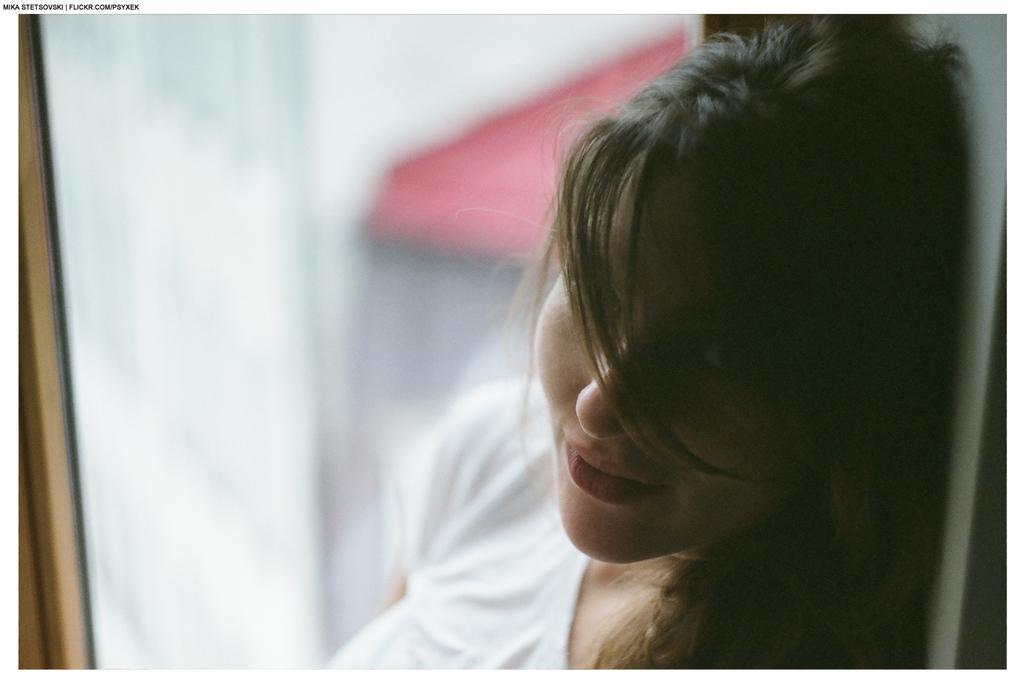Who is the main subject in the foreground of the image? There is a lady in the foreground of the image. What can be seen in the background of the image? There is a glass wall in the background of the image. What type of print can be seen on the maid's uniform in the image? There is no maid present in the image, and therefore no uniform or print to observe. 